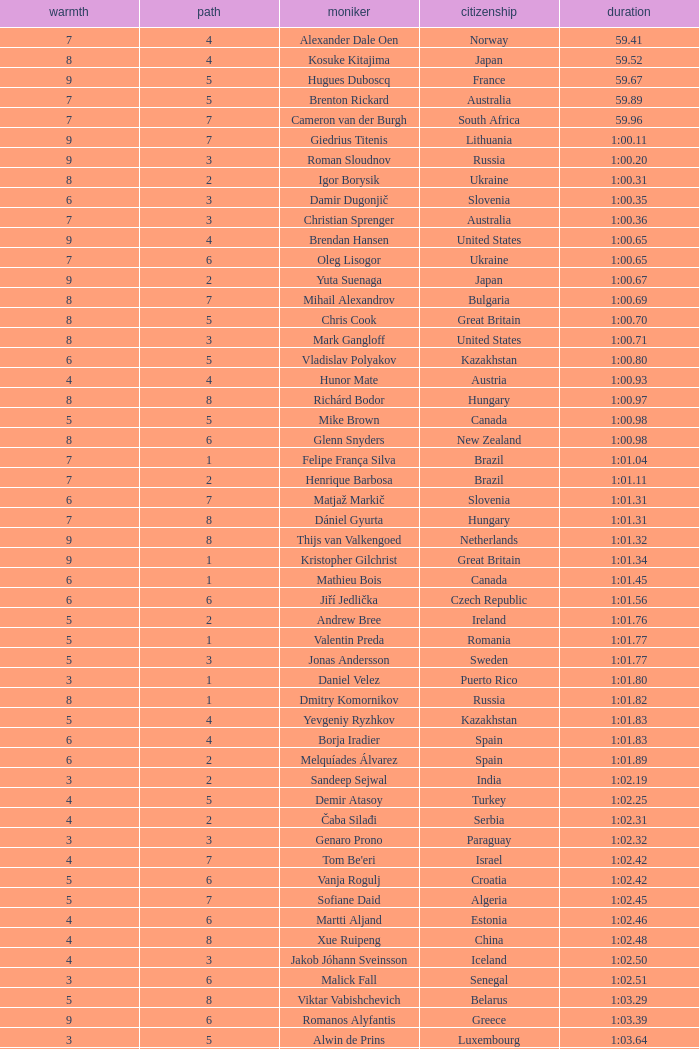What is the time in a heat smaller than 5, in Lane 5, for Vietnam? 1:06.36. 